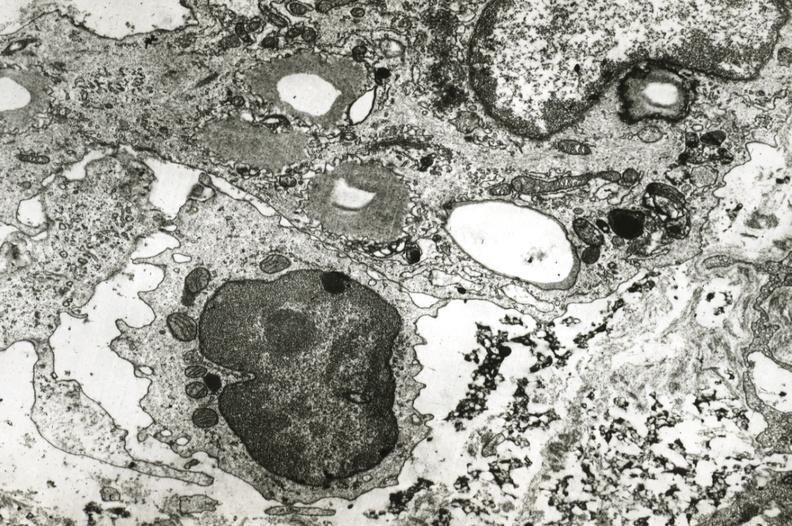does this image show smooth muscle cell with lipid monocyte and precipitated lipid in interstitial space?
Answer the question using a single word or phrase. Yes 